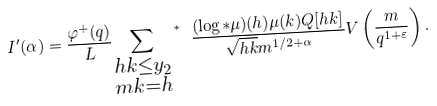<formula> <loc_0><loc_0><loc_500><loc_500>I ^ { \prime } ( \alpha ) = \frac { \varphi ^ { + } ( q ) } { L } { \sum _ { \substack { h k \leq y _ { 2 } \\ m k = h } } \, } ^ { * } \ \frac { ( \log * \mu ) ( h ) \mu ( k ) Q [ h k ] } { \sqrt { h k } m ^ { 1 / 2 + \alpha } } V \left ( \frac { m } { q ^ { 1 + \varepsilon } } \right ) .</formula> 